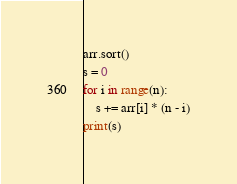Convert code to text. <code><loc_0><loc_0><loc_500><loc_500><_Python_>arr.sort()
s = 0
for i in range(n):
    s += arr[i] * (n - i)
print(s)
</code> 